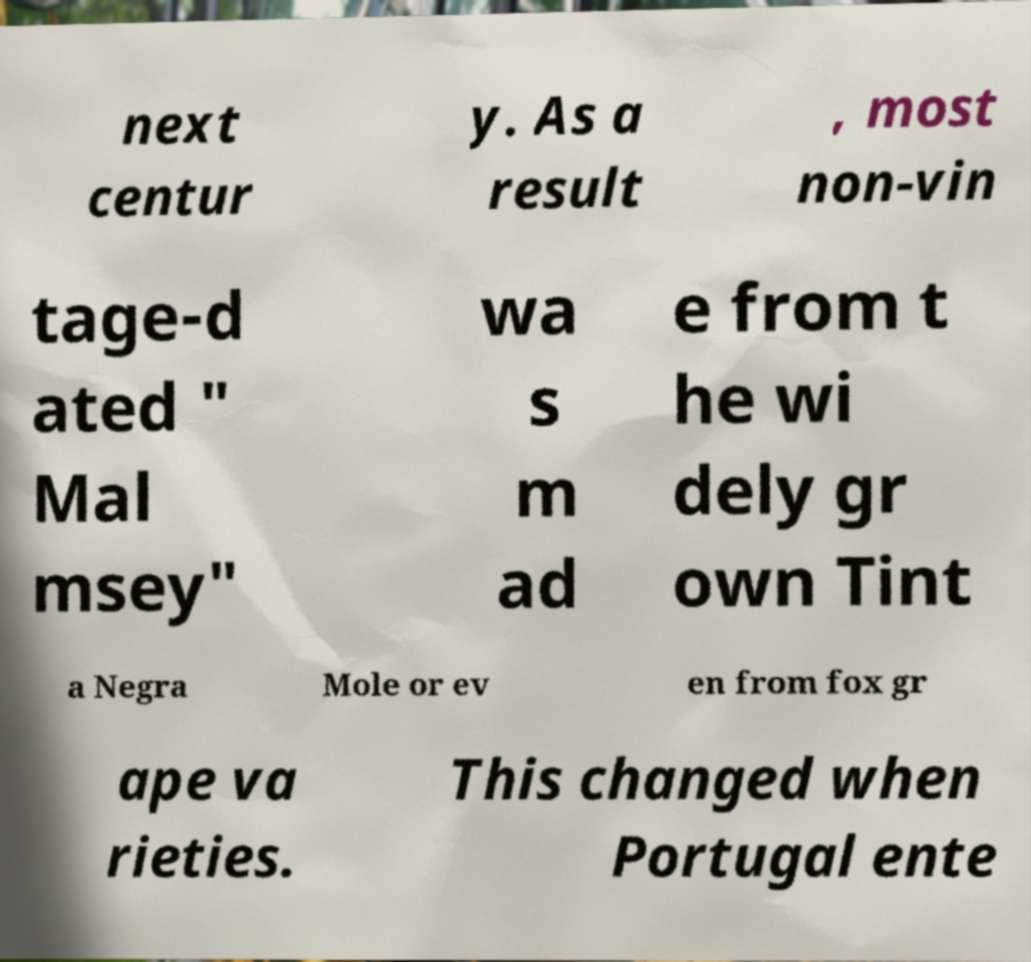Could you extract and type out the text from this image? next centur y. As a result , most non-vin tage-d ated " Mal msey" wa s m ad e from t he wi dely gr own Tint a Negra Mole or ev en from fox gr ape va rieties. This changed when Portugal ente 